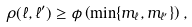Convert formula to latex. <formula><loc_0><loc_0><loc_500><loc_500>\rho ( \ell , \ell ^ { \prime } ) \geq \phi \left ( \min \{ m _ { \ell } , m _ { \ell ^ { \prime } } \} \right ) ,</formula> 